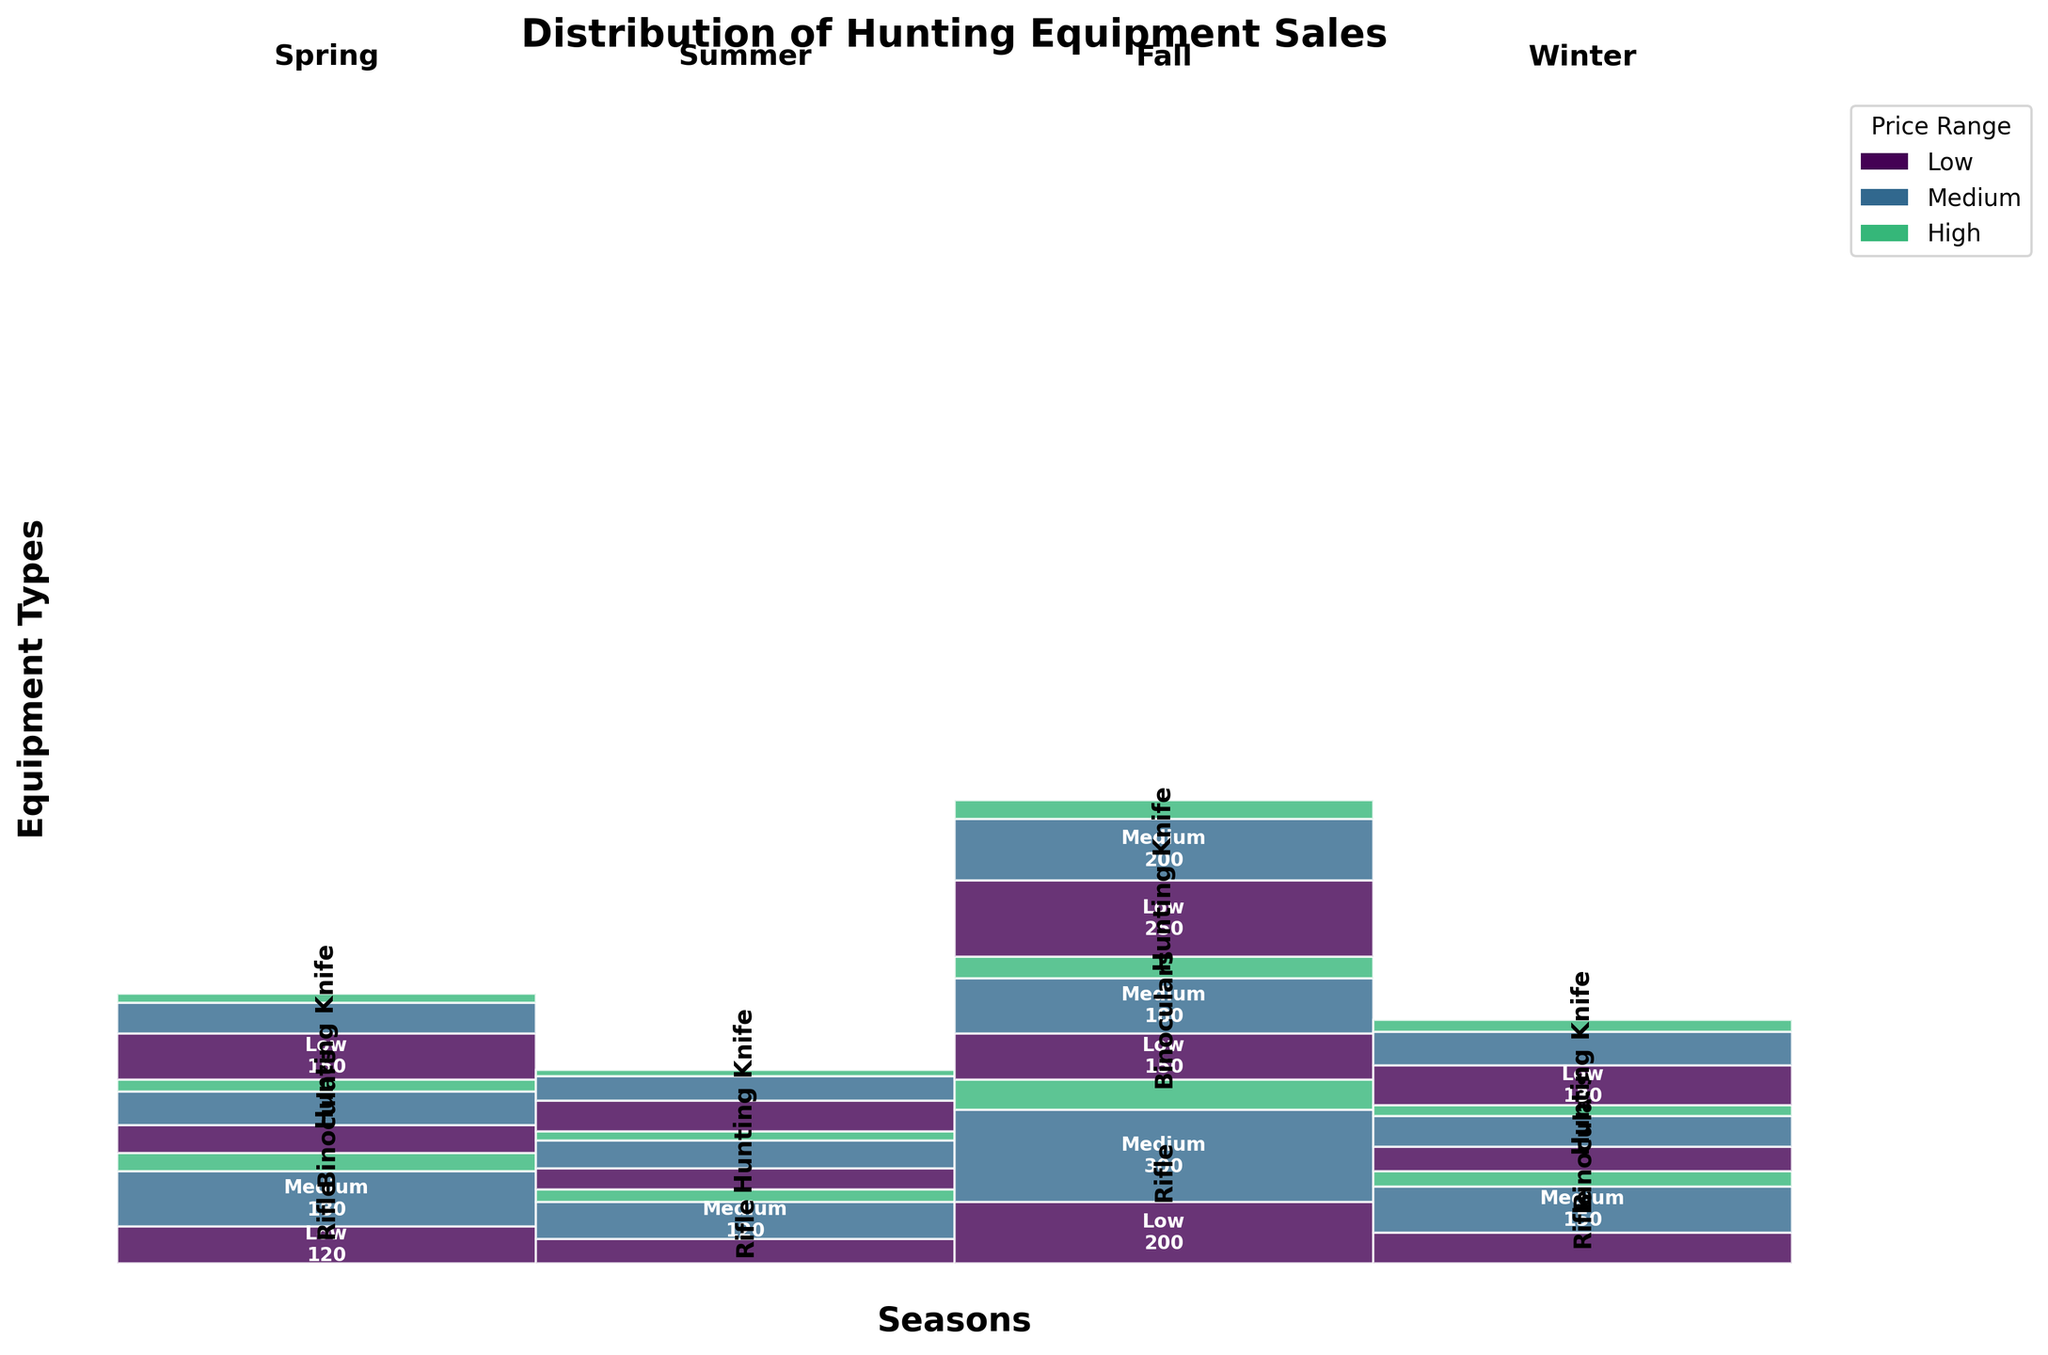What's the title of the plot? The title is usually displayed above the plot, often in bold and larger font. For this plot, it's stated in the code as "Distribution of Hunting Equipment Sales".
Answer: Distribution of Hunting Equipment Sales Which season has the most sales for rifles in the medium price range? To determine this, look for the segment labeled "Rifle" in the medium price range for each season. Compare the sizes of these segments. The Fall segment appears largest for this category.
Answer: Fall What's the sum of sales for hunting knives in the low price range across all seasons? Sum the sales for hunting knives in the low price range for Spring (150), Summer (100), Fall (250), and Winter (130): 150 + 100 + 250 + 130 = 630.
Answer: 630 In which season are binoculars in the high price range sold the least? Compare the size of the high price range segment for binoculars across all seasons. The smallest segment appears in Summer.
Answer: Summer Which equipment type and price range combination has the highest sales in Winter? For Winter, identify the largest segment across all categories and price ranges. The low price range segment for hunting knives is the largest.
Answer: Hunting Knife, Low Compare the sales of medium-priced binoculars in Spring to those in Fall. Which season has more sales? Locate the medium price range for binoculars in both Spring and Fall; compare their segment sizes. Fall has more sales with 180 compared to Spring's 110.
Answer: Fall How do the sales of high-priced rifles in Spring compare to those in Winter? Identify the high price range segment for rifles in both Spring (60) and Winter (50) and compare the sales: 60 is greater than 50.
Answer: Spring Which season has the most balanced sales distribution across all price ranges for rifles? A balanced distribution has segments of relatively equal size within the same equipment type and across price ranges. Spring shows a relatively balanced distribution for rifles across low, medium, and high price ranges.
Answer: Spring What's the average sales of medium-priced hunting knives per season? Sum the sales for medium-priced hunting knives in each season and then divide by the number of seasons: (100 + 80 + 200 + 110) / 4 = 490 / 4 = 122.5.
Answer: 122.5 Between Spring and Summer, which has higher overall sales for low-priced equipment? Compare the total sales from low price range segments for all equipment types in Spring and Summer: Spring (120+90+150=360) and Summer (80+70+100=250). Spring has higher overall sales in the low price range.
Answer: Spring 